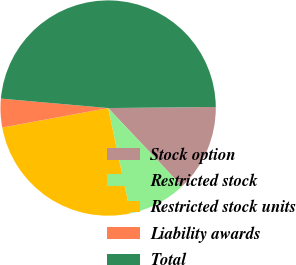Convert chart. <chart><loc_0><loc_0><loc_500><loc_500><pie_chart><fcel>Stock option<fcel>Restricted stock<fcel>Restricted stock units<fcel>Liability awards<fcel>Total<nl><fcel>13.12%<fcel>8.71%<fcel>25.44%<fcel>4.29%<fcel>48.44%<nl></chart> 